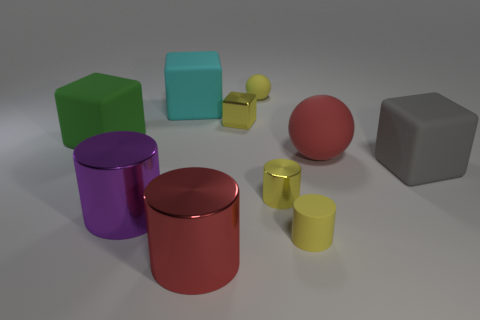Subtract 2 cubes. How many cubes are left? 2 Subtract all cyan cylinders. Subtract all red balls. How many cylinders are left? 4 Subtract all cubes. How many objects are left? 6 Subtract 0 blue balls. How many objects are left? 10 Subtract all large purple rubber cylinders. Subtract all red metallic things. How many objects are left? 9 Add 8 small yellow shiny things. How many small yellow shiny things are left? 10 Add 3 tiny cyan metallic cylinders. How many tiny cyan metallic cylinders exist? 3 